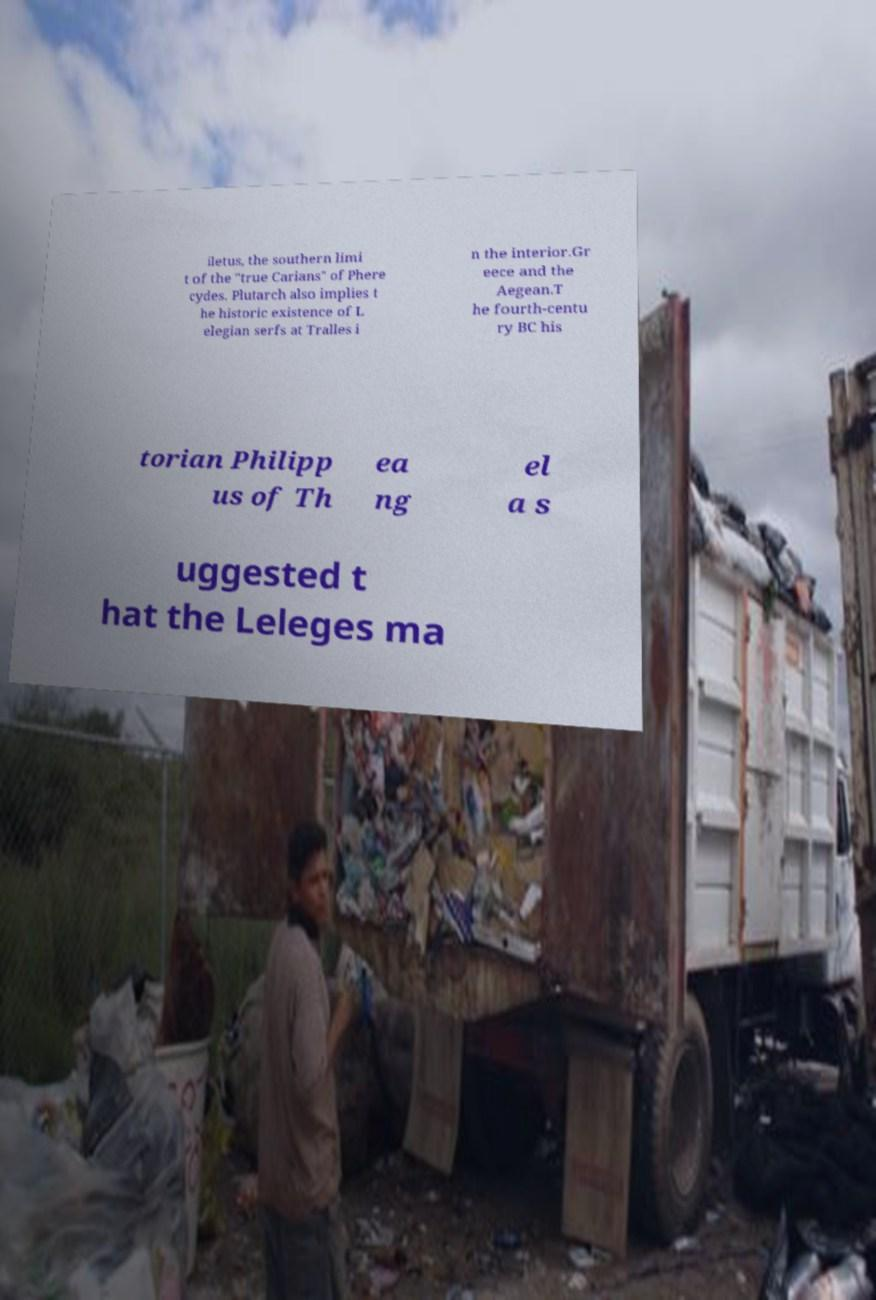I need the written content from this picture converted into text. Can you do that? iletus, the southern limi t of the "true Carians" of Phere cydes. Plutarch also implies t he historic existence of L elegian serfs at Tralles i n the interior.Gr eece and the Aegean.T he fourth-centu ry BC his torian Philipp us of Th ea ng el a s uggested t hat the Leleges ma 